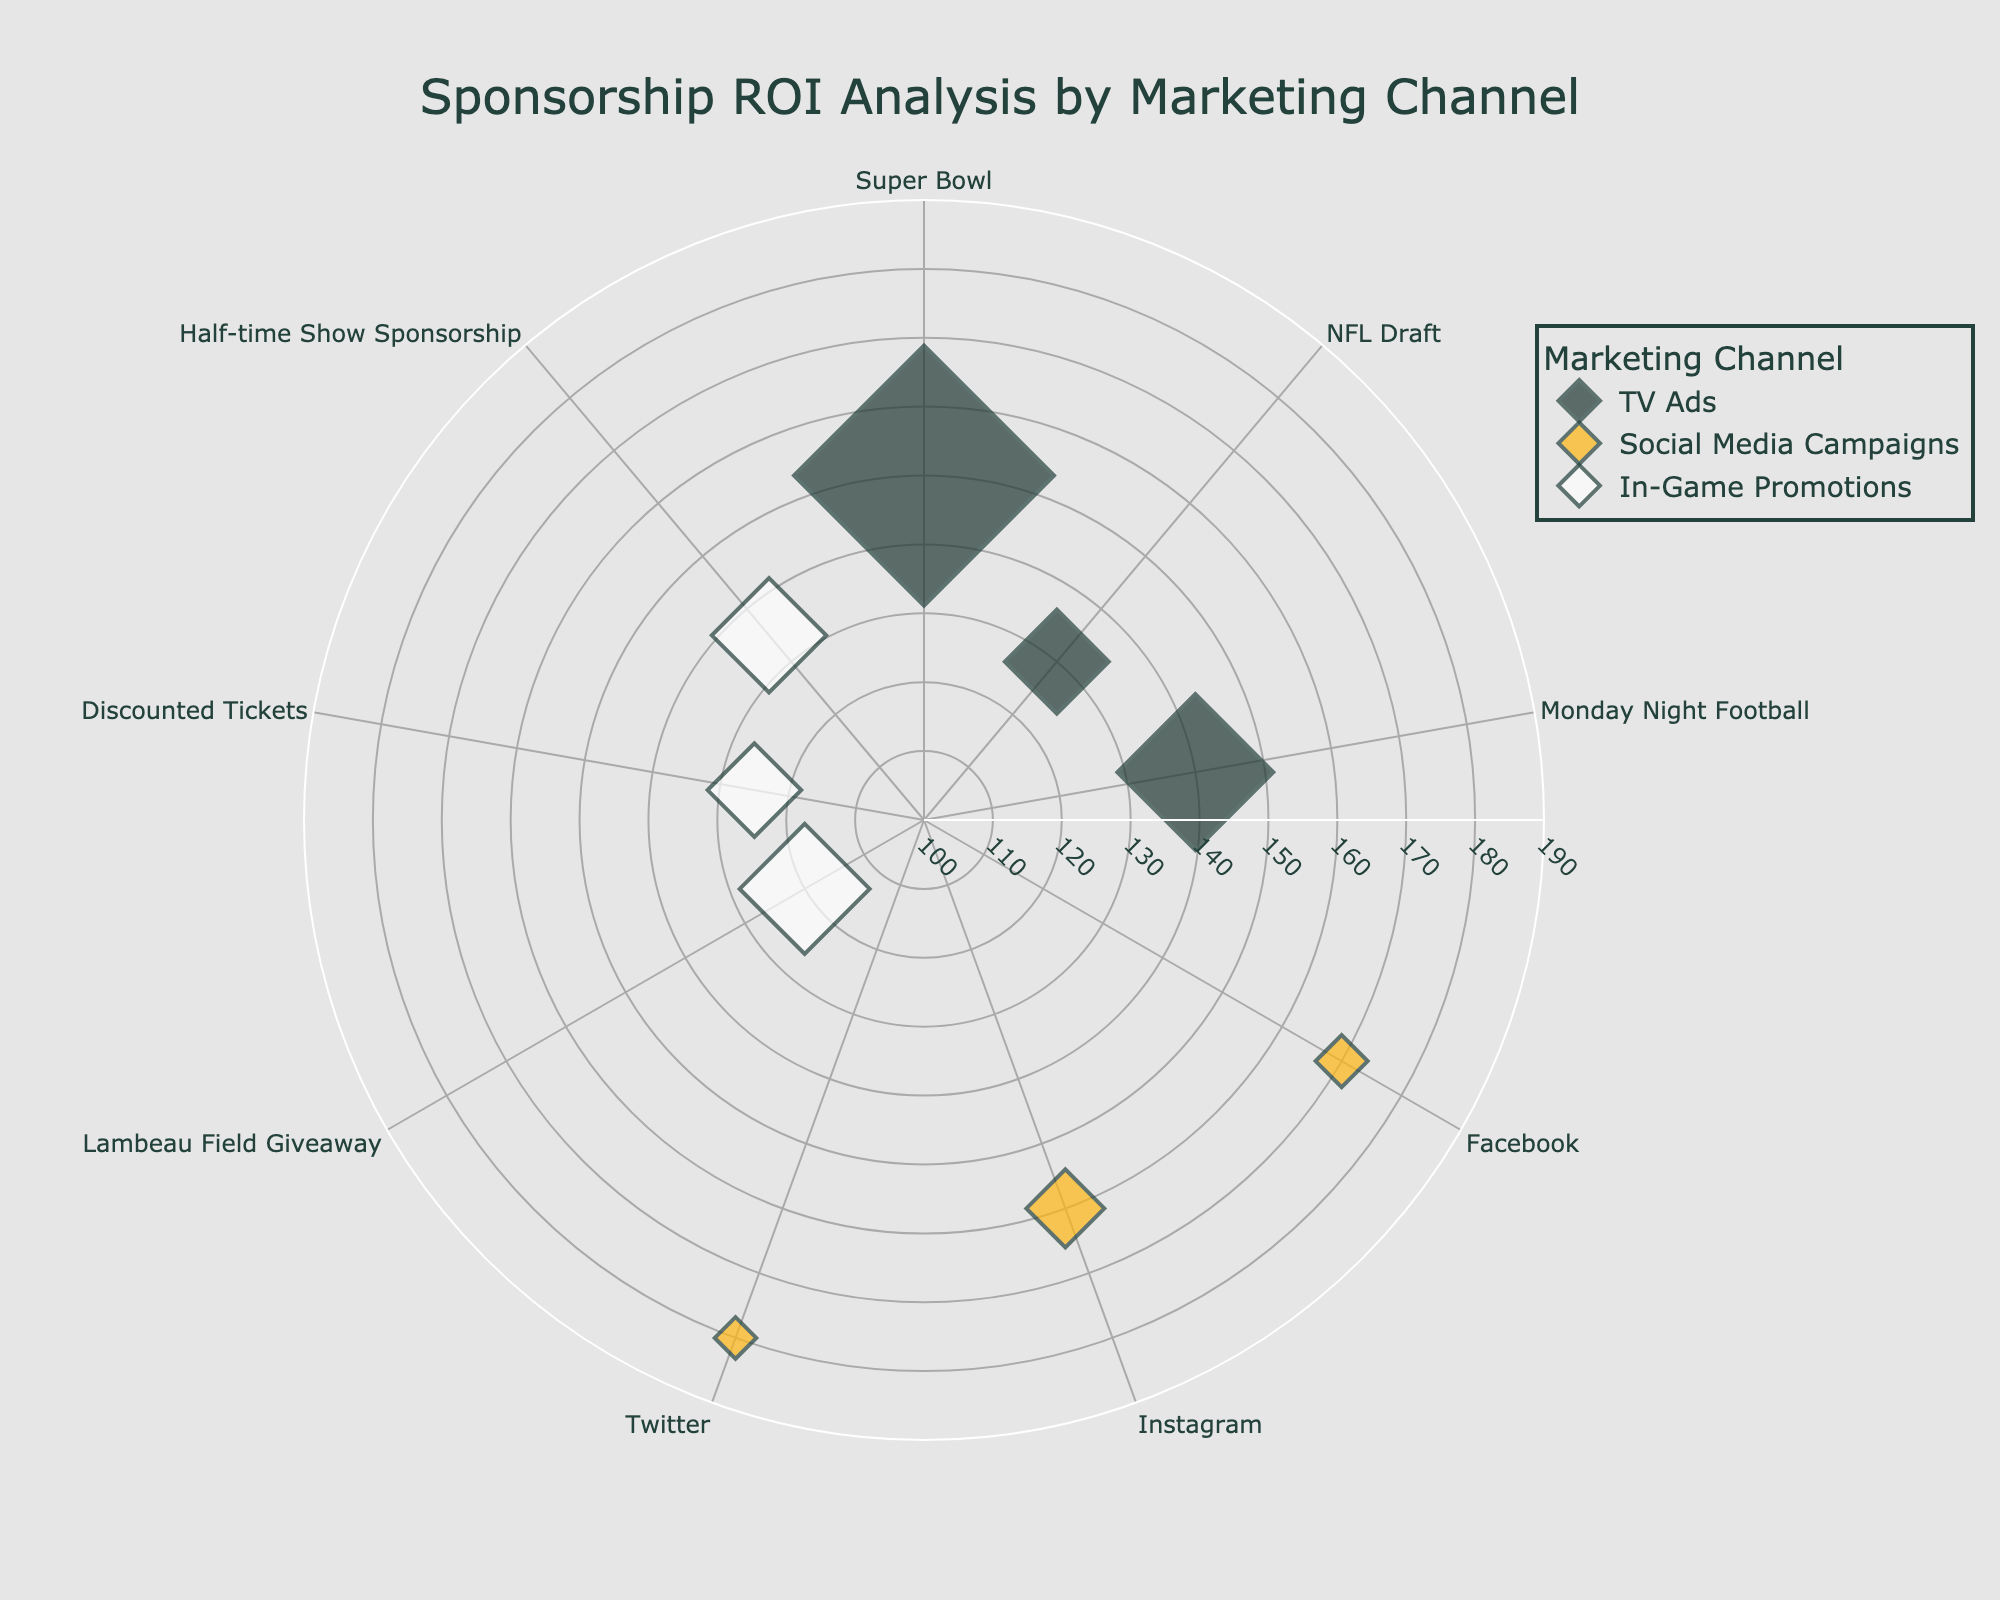What is the ROI for the Monday Night Football TV ad? Locate the marker labeled "Monday Night Football" in the "TV Ads" category. The marker's position on the radial axis shows the ROI value.
Answer: 140% Which marketing channel achieved the highest ROI? Compare the radial axis positions of all markers. The marker for the Twitter campaign in the "Social Media Campaigns" channel has the highest radial value.
Answer: Social Media Campaigns (Twitter) What is the total spend for TV Ads? Add the spend values for all TV Ads entries: $500,000 (Super Bowl) + $200,000 (NFL Draft) + $300,000 (Monday Night Football).
Answer: $1,000,000 Which event related to In-Game Promotions has the lowest ROI? Locate the markers associated with In-Game Promotions and compare their radial axis values. The marker for the "Lambeau Field Giveaway" has the lowest ROI.
Answer: Lambeau Field Giveaway What is the average ROI for Social Media Campaigns? Calculate the mean of the ROI values for Social Media Campaigns: (170% + 160% + 180%) / 3.
Answer: 170% Which marketing channel has the largest marker size? Look for the markers with the largest radii, indicating spend size. TV Ads, particularly the Super Bowl, has the largest marker size.
Answer: TV Ads (Super Bowl) Compare the ROI of Facebook and Instagram Social Media Campaigns. Which is higher? Locate the markers labeled "Facebook" and "Instagram" under Social Media Campaigns and compare their radial axis positions. The radial value for Facebook is higher.
Answer: Facebook Which event had a spend of $220,000? Find the marker that represents a $220,000 spend in one of the marketing channels. The marker for the "Half-time Show Sponsorship" under In-Game Promotions matches this spend.
Answer: Half-time Show Sponsorship How does the ROI of the Lambeau Field Giveaway compare to the Discounted Tickets promotion? Compare the radial positions of the markers for "Lambeau Field Giveaway" and "Discounted Tickets" under In-Game Promotions. The ROI for the Discounted Tickets promotion is higher.
Answer: Discounted Tickets promotion has higher ROI What is the average spend for In-Game Promotions? Calculate the mean of the spend values for In-Game Promotions: ($250,000 + $180,000 + $220,000) / 3.
Answer: $216,666.67 